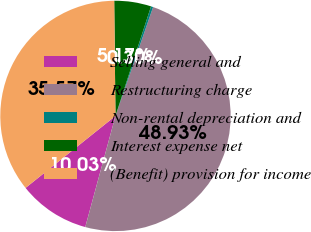Convert chart to OTSL. <chart><loc_0><loc_0><loc_500><loc_500><pie_chart><fcel>Selling general and<fcel>Restructuring charge<fcel>Non-rental depreciation and<fcel>Interest expense net<fcel>(Benefit) provision for income<nl><fcel>10.03%<fcel>48.93%<fcel>0.3%<fcel>5.17%<fcel>35.57%<nl></chart> 